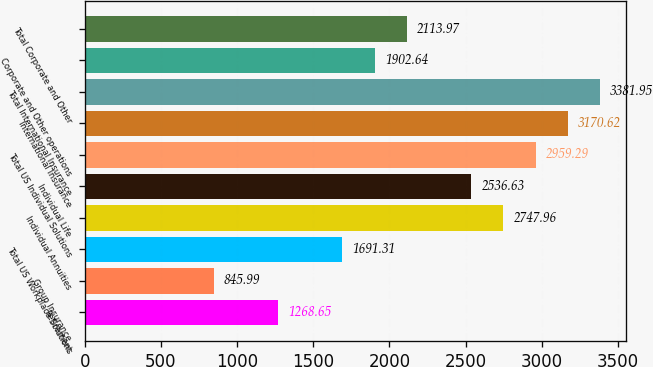<chart> <loc_0><loc_0><loc_500><loc_500><bar_chart><fcel>Retirement<fcel>Group Insurance<fcel>Total US Workplace Solutions<fcel>Individual Annuities<fcel>Individual Life<fcel>Total US Individual Solutions<fcel>International Insurance<fcel>Total International Insurance<fcel>Corporate and Other operations<fcel>Total Corporate and Other<nl><fcel>1268.65<fcel>845.99<fcel>1691.31<fcel>2747.96<fcel>2536.63<fcel>2959.29<fcel>3170.62<fcel>3381.95<fcel>1902.64<fcel>2113.97<nl></chart> 